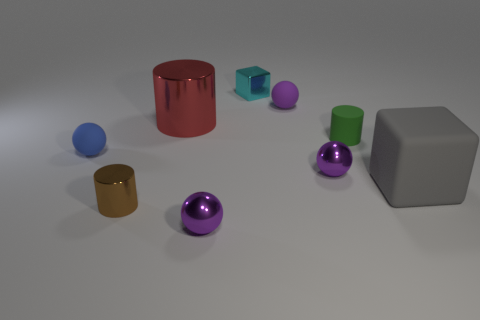Add 1 tiny brown metal cylinders. How many objects exist? 10 Subtract all small purple spheres. How many spheres are left? 1 Add 1 tiny blue balls. How many tiny blue balls are left? 2 Add 6 blue blocks. How many blue blocks exist? 6 Subtract all blue spheres. How many spheres are left? 3 Subtract 1 brown cylinders. How many objects are left? 8 Subtract all cylinders. How many objects are left? 6 Subtract 1 cylinders. How many cylinders are left? 2 Subtract all brown blocks. Subtract all red cylinders. How many blocks are left? 2 Subtract all green cylinders. How many cyan cubes are left? 1 